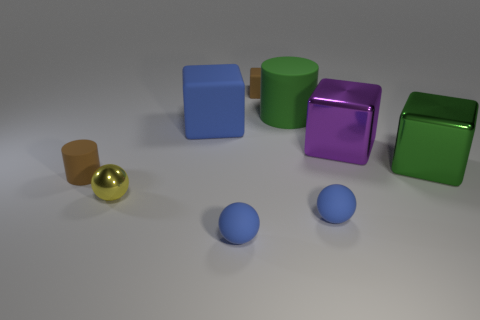Subtract all small yellow metallic balls. How many balls are left? 2 Add 1 small yellow objects. How many objects exist? 10 Subtract 1 spheres. How many spheres are left? 2 Subtract all green cylinders. How many cylinders are left? 1 Subtract all green cylinders. Subtract all brown spheres. How many cylinders are left? 1 Subtract all yellow blocks. How many yellow balls are left? 1 Subtract all green cylinders. Subtract all spheres. How many objects are left? 5 Add 4 big green metal things. How many big green metal things are left? 5 Add 8 small rubber cylinders. How many small rubber cylinders exist? 9 Subtract 1 green blocks. How many objects are left? 8 